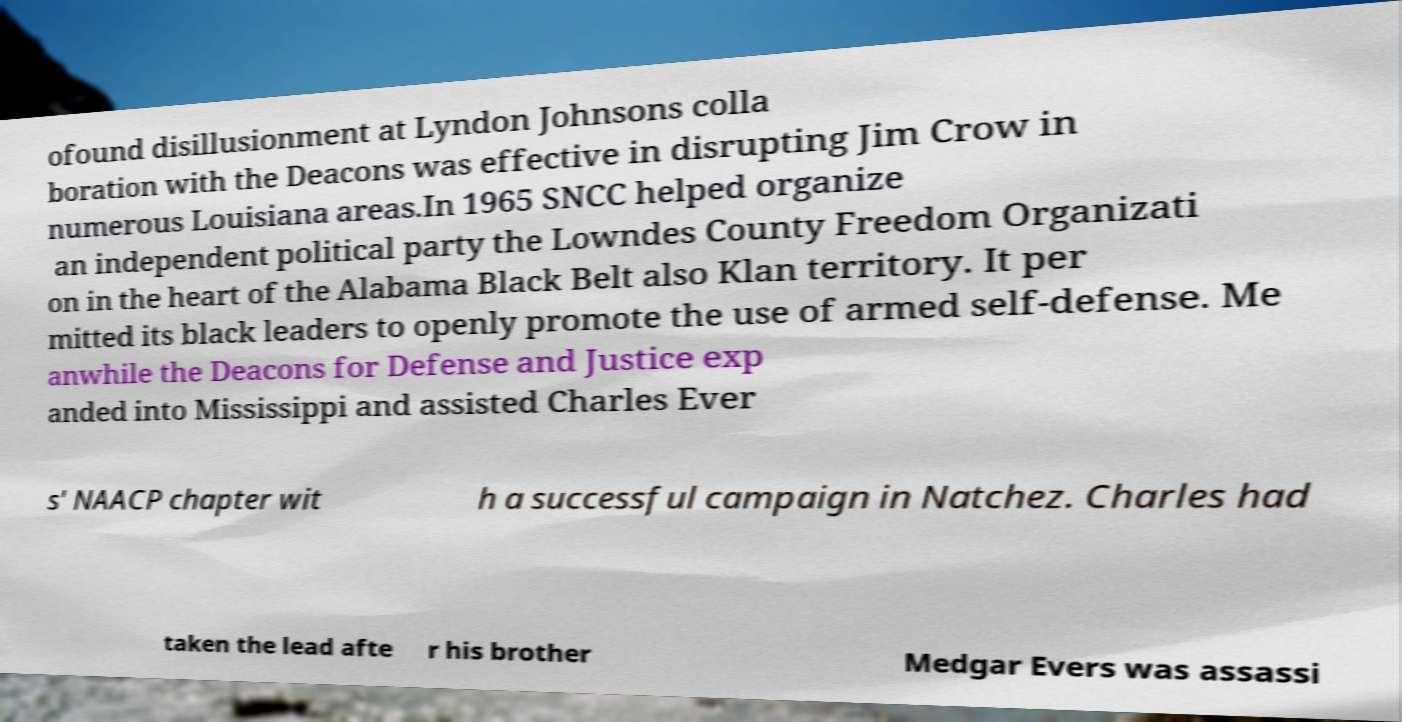Could you extract and type out the text from this image? ofound disillusionment at Lyndon Johnsons colla boration with the Deacons was effective in disrupting Jim Crow in numerous Louisiana areas.In 1965 SNCC helped organize an independent political party the Lowndes County Freedom Organizati on in the heart of the Alabama Black Belt also Klan territory. It per mitted its black leaders to openly promote the use of armed self-defense. Me anwhile the Deacons for Defense and Justice exp anded into Mississippi and assisted Charles Ever s' NAACP chapter wit h a successful campaign in Natchez. Charles had taken the lead afte r his brother Medgar Evers was assassi 